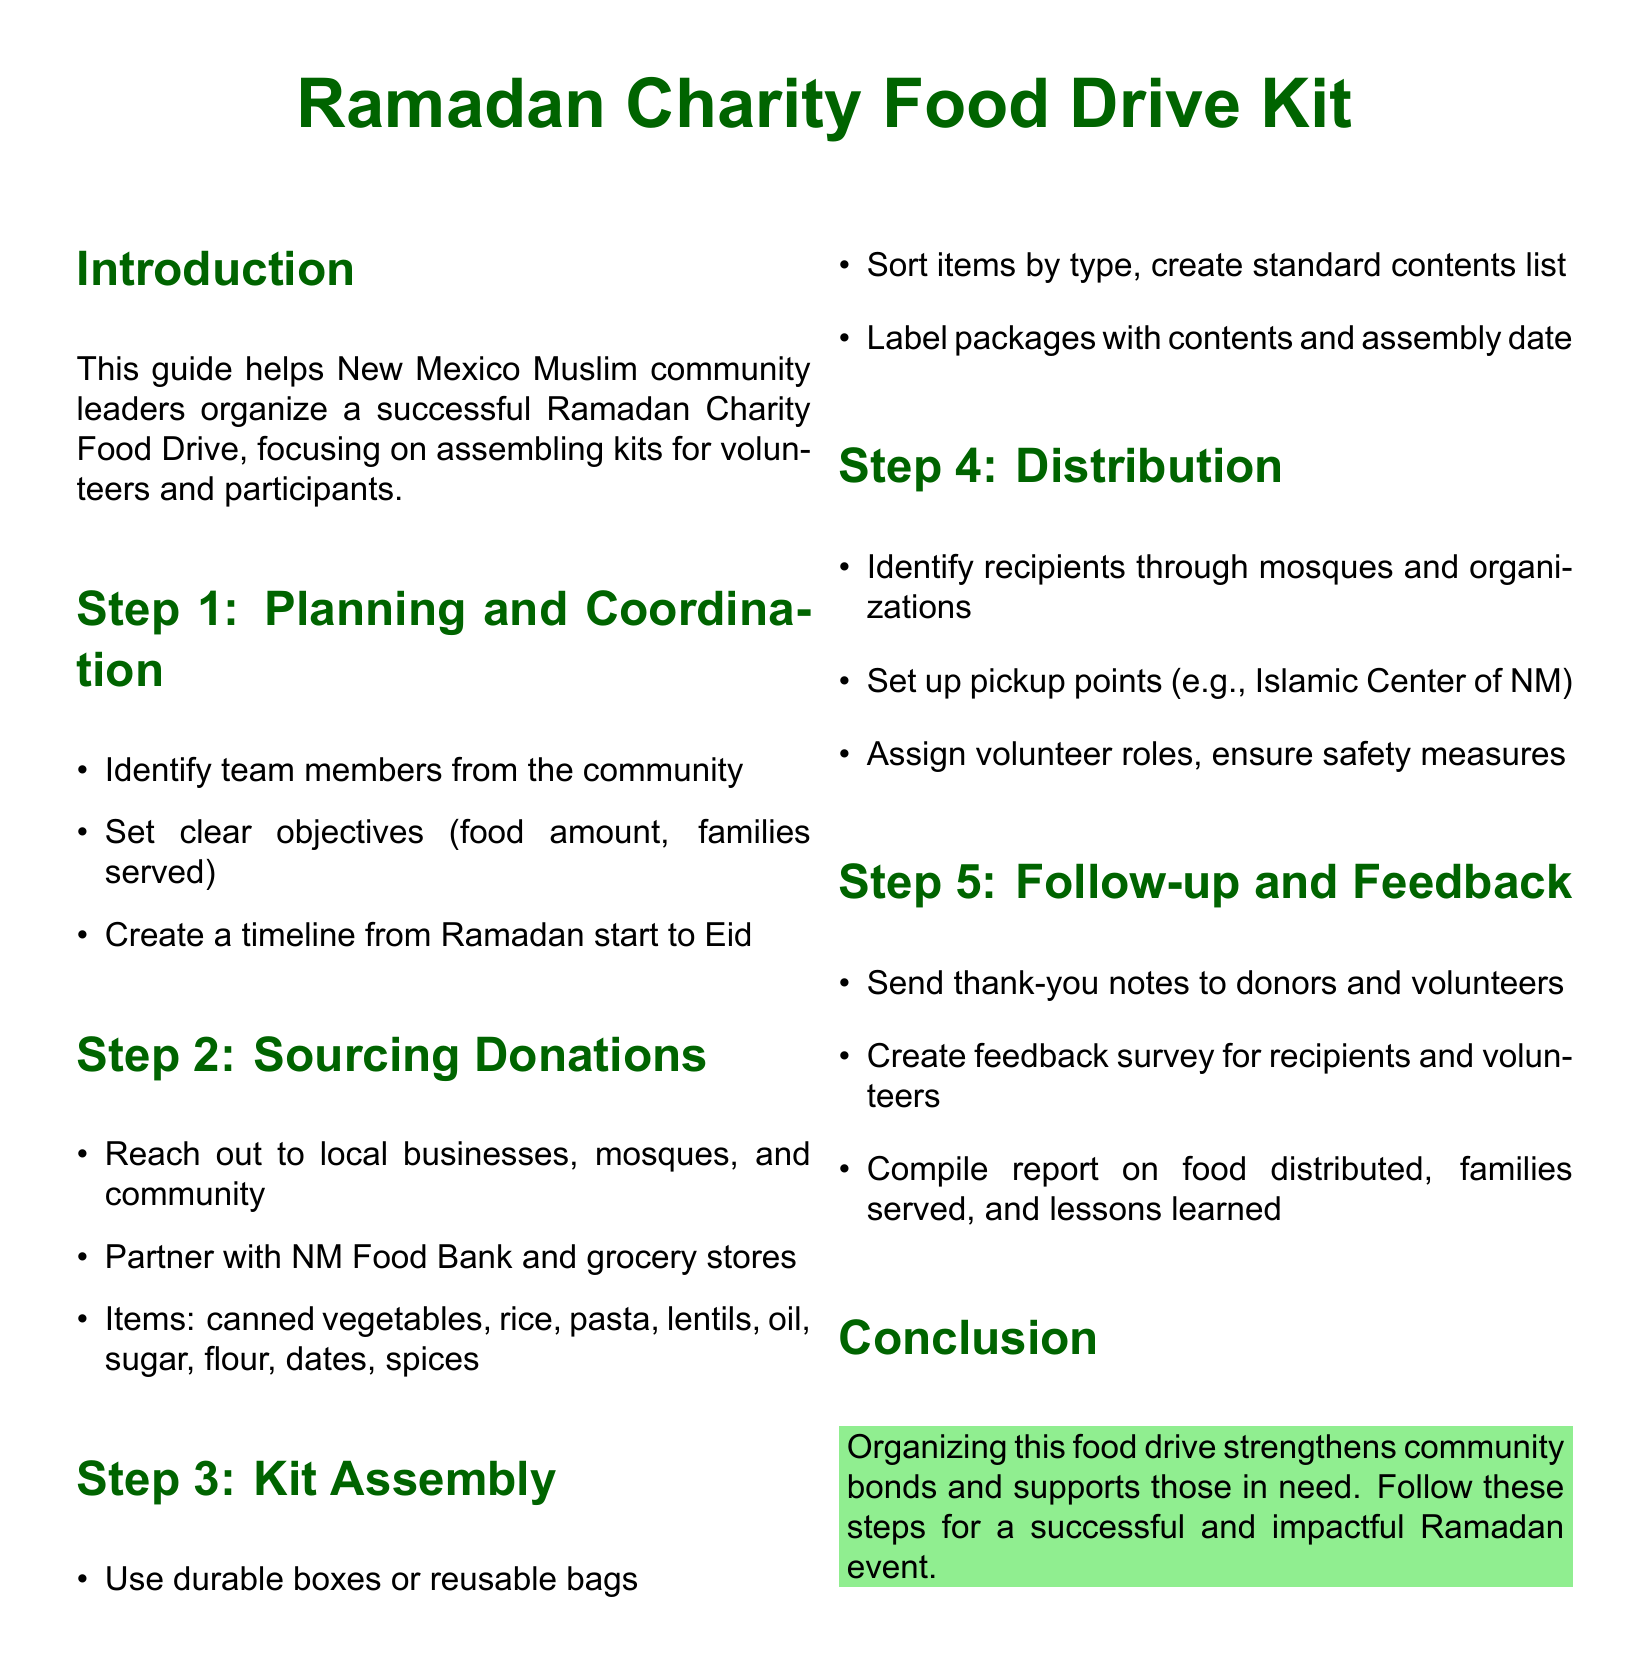What is the main focus of the guide? The main focus of the guide is to help organize a successful Ramadan Charity Food Drive.
Answer: Organizing a successful Ramadan Charity Food Drive How many steps are outlined for the food drive? The document outlines a total of five steps for the food drive.
Answer: Five steps What organization can be partnered with for donations? The New Mexico Food Bank is mentioned as a potential partner for sourcing donations.
Answer: NM Food Bank What items are included in the kit assembly? The items listed for kit assembly include canned vegetables, rice, pasta, lentils, oil, sugar, flour, dates, and spices.
Answer: Canned vegetables, rice, pasta, lentils, oil, sugar, flour, dates, spices What should be done after the food drive? After the food drive, a report should be compiled on the food distributed and families served.
Answer: Compile report Who should receive thank-you notes? Thank-you notes should be sent to donors and volunteers.
Answer: Donors and volunteers 